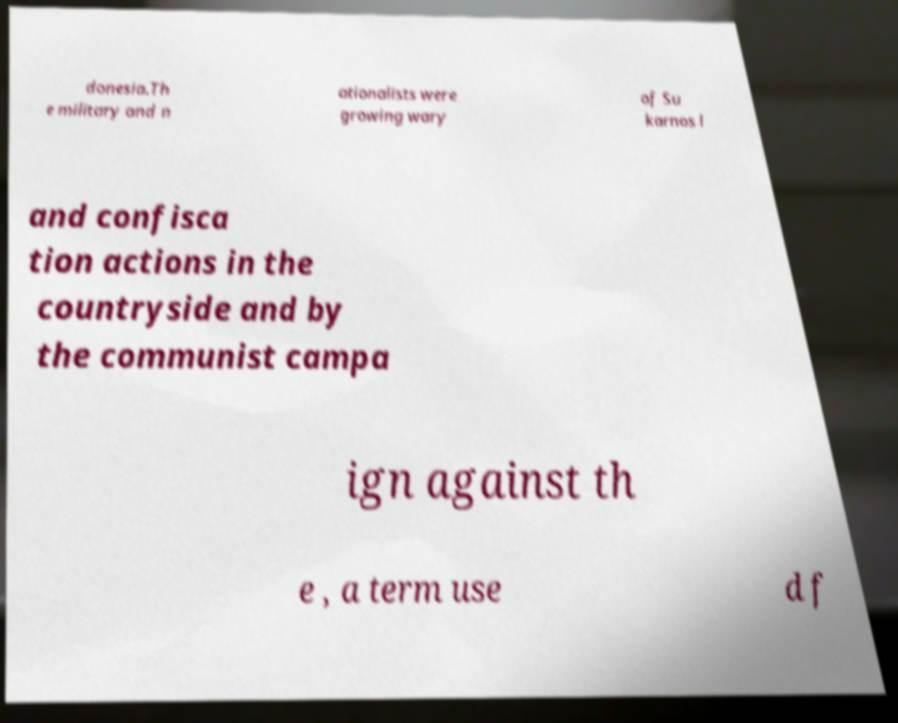Please read and relay the text visible in this image. What does it say? donesia.Th e military and n ationalists were growing wary of Su karnos l and confisca tion actions in the countryside and by the communist campa ign against th e , a term use d f 